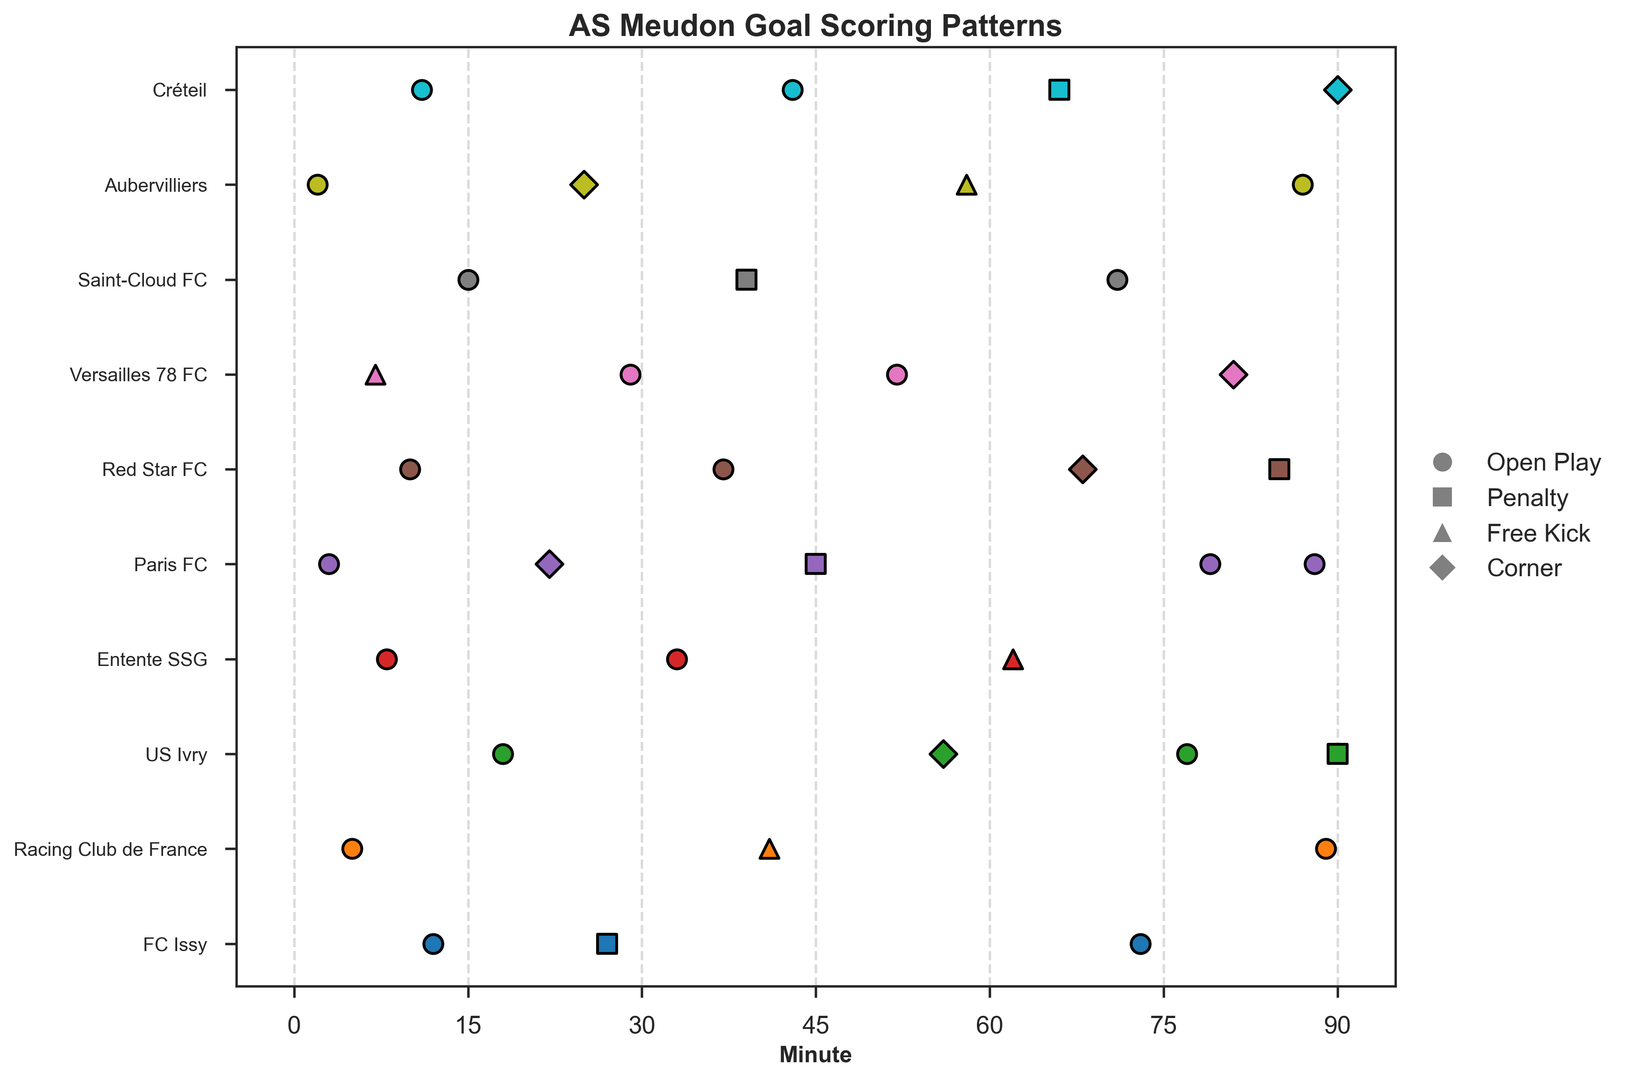Which opponent had the most different types of goals scored against them? Count the different goal types for each opponent. US Ivry had goals from Open Play, Penalty, and Corner types.
Answer: US Ivry What match had the earliest goal scored? Check the earliest minute for a goal across all matches. The earliest goal was at minute 2 against Aubervilliers.
Answer: Aubervilliers Which goal type had the most goals scored in the first half (0-45 minutes)? Count the number of goals by type within the first 45 minutes. 'Open Play' had the most goals, with 10 such goals in the first half.
Answer: Open Play Did AS Meudon score more goals in the first half or the second half? Compare the total goals scored in the first half (0-45) and the second half (46-90). There were 14 goals in the first half and 16 in the second half.
Answer: Second half During which match did the latest goal(s) occur? Find the latest minute for a goal across all matches. The latest goal was at minute 90, which happened against both US Ivry and Créteil.
Answer: US Ivry and Créteil Which team conceded the most penalties from AS Meudon? Count the penalties scored against each opponent. Both Paris FC and Red Star FC had 1 penalty each.
Answer: Paris FC and Red Star FC How many Free Kick goals were scored after the 60th minute? Count the number of Free Kick goals after the 60th minute. There were 2 Free Kick goals (against Aubervilliers and Entente SSG).
Answer: 2 Which match involved goals scored in all four ways (Open Play, Penalty, Free Kick, Corner)? Check which matches have all goal types represented. No match had all four ways of goals scored.
Answer: None What is the average minute of goals scored from Open Play? Calculate the average minute for all "Open Play" goals. Sum all minutes for Open Play goals and divide by the number of Open Play goals. (12+73+5+89+18+77+8+33+3+79+88+10+37+29+52+15+71+2+11+43) / 20 = 32.4
Answer: 32.4 Which opponent had goals scored against them at the most varied times? Determine the range of minutes for goals scored against each opponent and compare the ranges. Racing Club de France had goals in the 5th, 41st, and 89th minutes, resulting in a range of 84 minutes.
Answer: Racing Club de France 